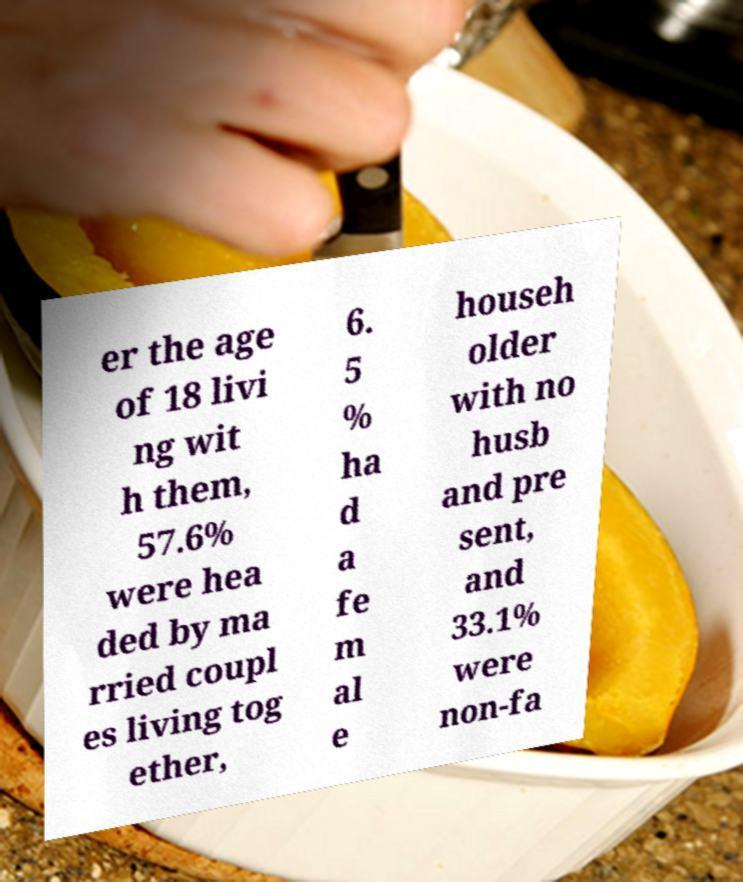Can you accurately transcribe the text from the provided image for me? er the age of 18 livi ng wit h them, 57.6% were hea ded by ma rried coupl es living tog ether, 6. 5 % ha d a fe m al e househ older with no husb and pre sent, and 33.1% were non-fa 